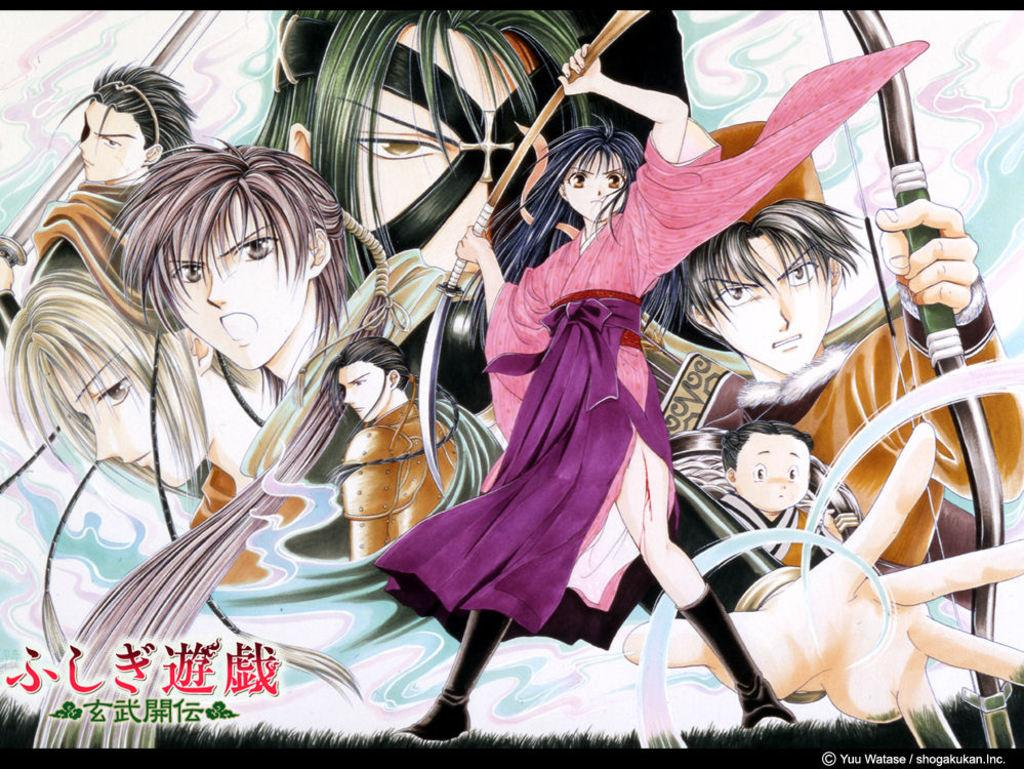What is the main subject of the image? The main subject of the image is an animated group of persons. Can you describe any text present in the image? Yes, there is text in Chinese in the bottom left of the image, and there is also text in the bottom right of the image. What type of straw is being used by the persons in the image? There is no straw visible in the image; it features an animated group of persons and text in Chinese. What kind of trouble are the persons in the image facing? There is no indication of trouble or any specific situation in the image; it simply shows an animated group of persons and text in Chinese. 